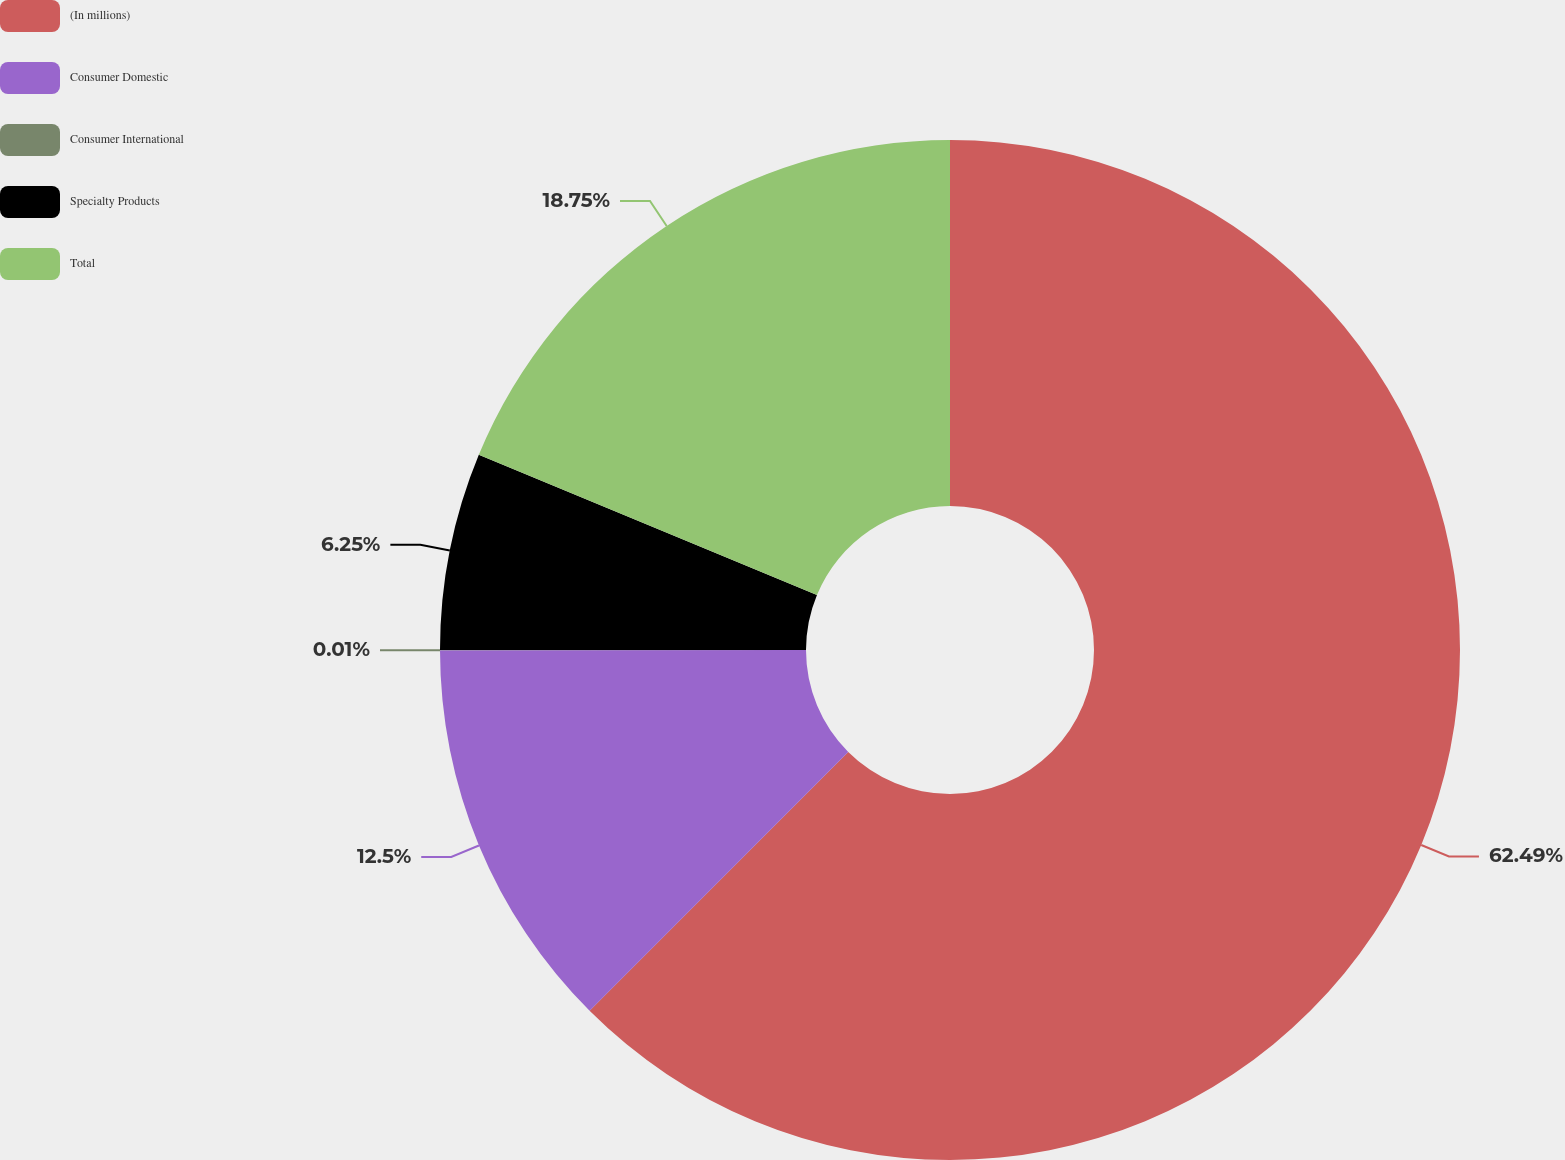Convert chart. <chart><loc_0><loc_0><loc_500><loc_500><pie_chart><fcel>(In millions)<fcel>Consumer Domestic<fcel>Consumer International<fcel>Specialty Products<fcel>Total<nl><fcel>62.49%<fcel>12.5%<fcel>0.01%<fcel>6.25%<fcel>18.75%<nl></chart> 